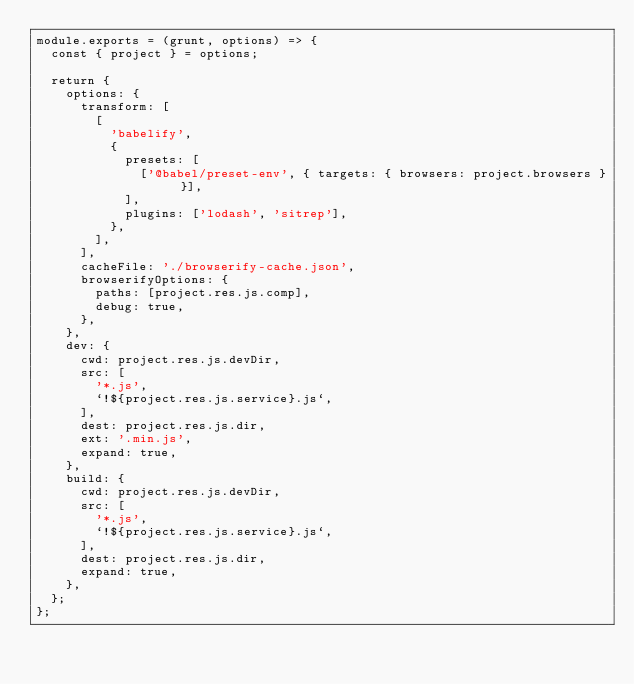<code> <loc_0><loc_0><loc_500><loc_500><_JavaScript_>module.exports = (grunt, options) => {
  const { project } = options;

  return {
    options: {
      transform: [
        [
          'babelify',
          {
            presets: [
              ['@babel/preset-env', { targets: { browsers: project.browsers } }],
            ],
            plugins: ['lodash', 'sitrep'],
          },
        ],
      ],
      cacheFile: './browserify-cache.json',
      browserifyOptions: {
        paths: [project.res.js.comp],
        debug: true,
      },
    },
    dev: {
      cwd: project.res.js.devDir,
      src: [
        '*.js',
        `!${project.res.js.service}.js`,
      ],
      dest: project.res.js.dir,
      ext: '.min.js',
      expand: true,
    },
    build: {
      cwd: project.res.js.devDir,
      src: [
        '*.js',
        `!${project.res.js.service}.js`,
      ],
      dest: project.res.js.dir,
      expand: true,
    },
  };
};
</code> 